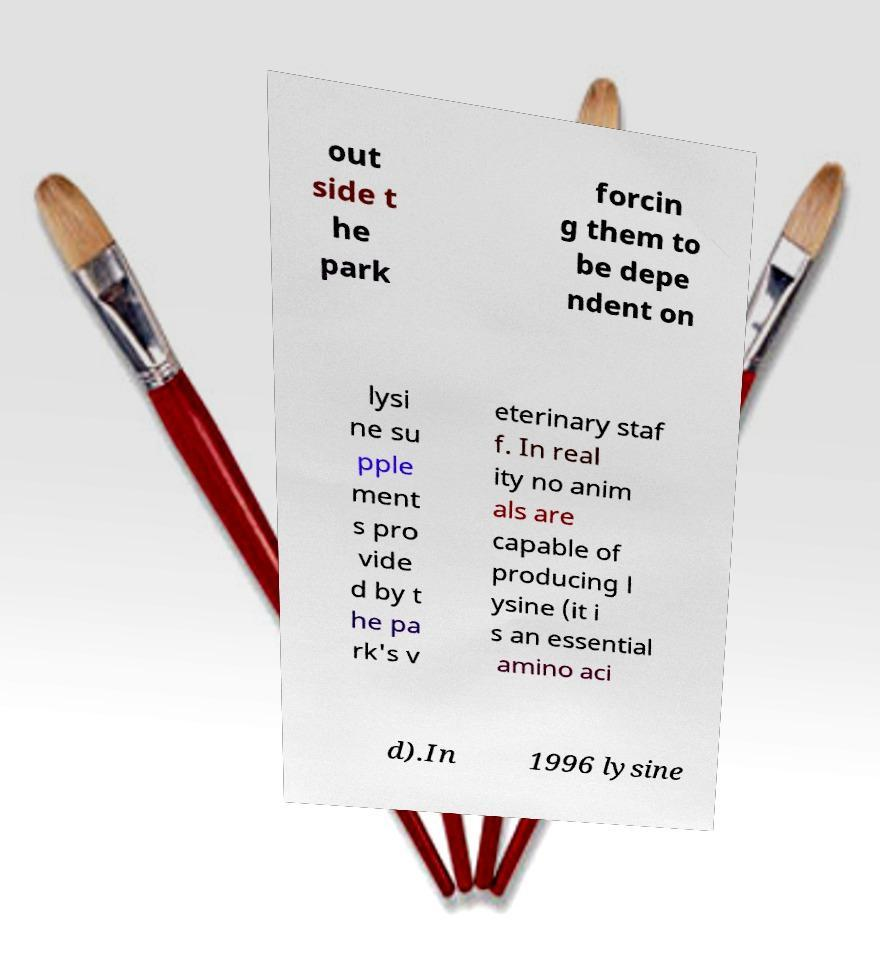What messages or text are displayed in this image? I need them in a readable, typed format. out side t he park forcin g them to be depe ndent on lysi ne su pple ment s pro vide d by t he pa rk's v eterinary staf f. In real ity no anim als are capable of producing l ysine (it i s an essential amino aci d).In 1996 lysine 